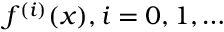Convert formula to latex. <formula><loc_0><loc_0><loc_500><loc_500>f ^ { ( i ) } ( x ) , i = 0 , 1 , \dots</formula> 